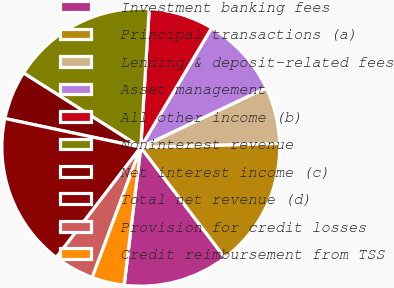Convert chart to OTSL. <chart><loc_0><loc_0><loc_500><loc_500><pie_chart><fcel>Investment banking fees<fcel>Principal transactions (a)<fcel>Lending & deposit-related fees<fcel>Asset management<fcel>All other income (b)<fcel>Noninterest revenue<fcel>Net interest income (c)<fcel>Total net revenue (d)<fcel>Provision for credit losses<fcel>Credit reimbursement from TSS<nl><fcel>12.26%<fcel>15.09%<fcel>6.6%<fcel>9.43%<fcel>7.55%<fcel>16.98%<fcel>5.66%<fcel>17.92%<fcel>4.72%<fcel>3.77%<nl></chart> 